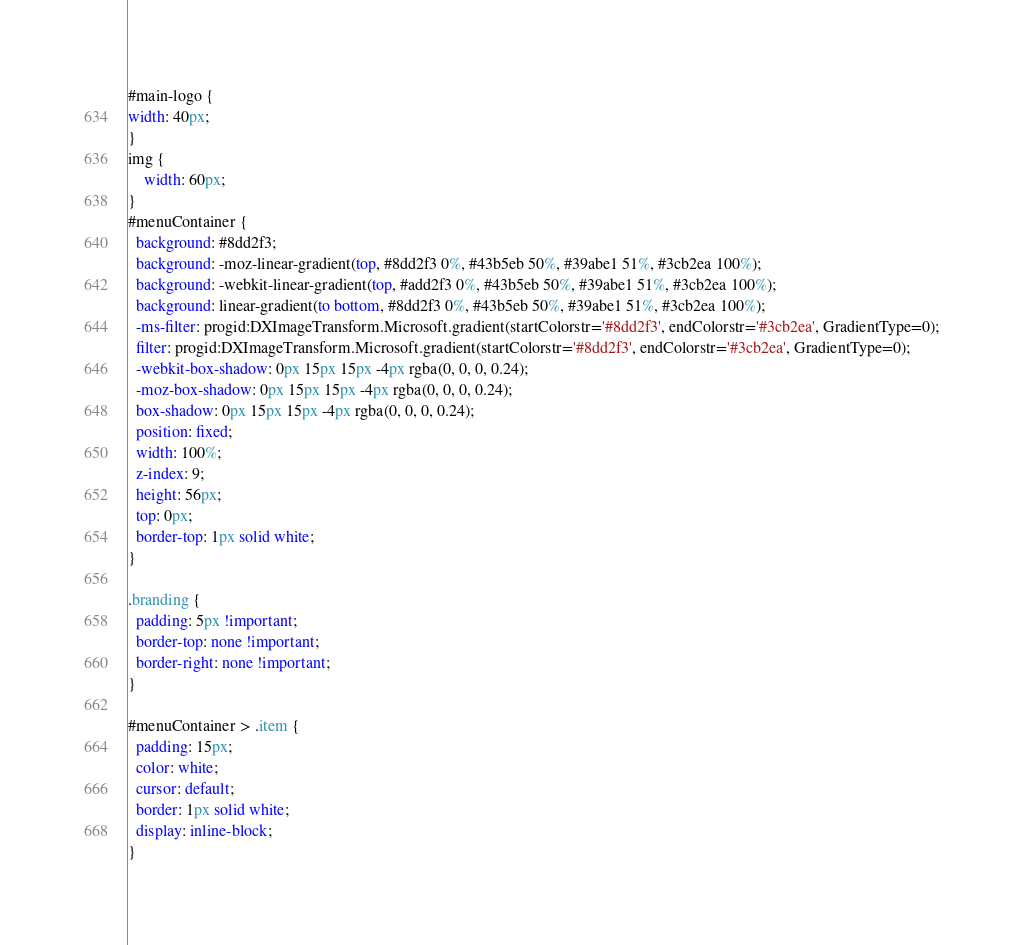Convert code to text. <code><loc_0><loc_0><loc_500><loc_500><_CSS_>#main-logo {
width: 40px;	
}
img {
	width: 60px;
}
#menuContainer {
  background: #8dd2f3;
  background: -moz-linear-gradient(top, #8dd2f3 0%, #43b5eb 50%, #39abe1 51%, #3cb2ea 100%);
  background: -webkit-linear-gradient(top, #add2f3 0%, #43b5eb 50%, #39abe1 51%, #3cb2ea 100%);
  background: linear-gradient(to bottom, #8dd2f3 0%, #43b5eb 50%, #39abe1 51%, #3cb2ea 100%);
  -ms-filter: progid:DXImageTransform.Microsoft.gradient(startColorstr='#8dd2f3', endColorstr='#3cb2ea', GradientType=0);
  filter: progid:DXImageTransform.Microsoft.gradient(startColorstr='#8dd2f3', endColorstr='#3cb2ea', GradientType=0);
  -webkit-box-shadow: 0px 15px 15px -4px rgba(0, 0, 0, 0.24);
  -moz-box-shadow: 0px 15px 15px -4px rgba(0, 0, 0, 0.24);
  box-shadow: 0px 15px 15px -4px rgba(0, 0, 0, 0.24);
  position: fixed;
  width: 100%;
  z-index: 9;
  height: 56px;
  top: 0px;
  border-top: 1px solid white;
}

.branding {
  padding: 5px !important;
  border-top: none !important;
  border-right: none !important;
}

#menuContainer > .item {
  padding: 15px;
  color: white;
  cursor: default;
  border: 1px solid white;
  display: inline-block;
}	
</code> 